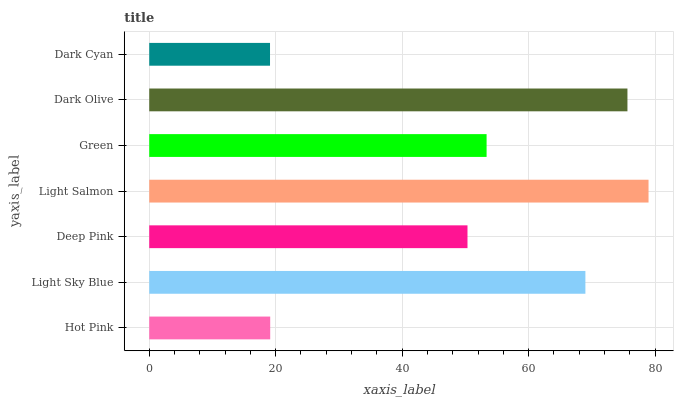Is Dark Cyan the minimum?
Answer yes or no. Yes. Is Light Salmon the maximum?
Answer yes or no. Yes. Is Light Sky Blue the minimum?
Answer yes or no. No. Is Light Sky Blue the maximum?
Answer yes or no. No. Is Light Sky Blue greater than Hot Pink?
Answer yes or no. Yes. Is Hot Pink less than Light Sky Blue?
Answer yes or no. Yes. Is Hot Pink greater than Light Sky Blue?
Answer yes or no. No. Is Light Sky Blue less than Hot Pink?
Answer yes or no. No. Is Green the high median?
Answer yes or no. Yes. Is Green the low median?
Answer yes or no. Yes. Is Light Sky Blue the high median?
Answer yes or no. No. Is Light Sky Blue the low median?
Answer yes or no. No. 